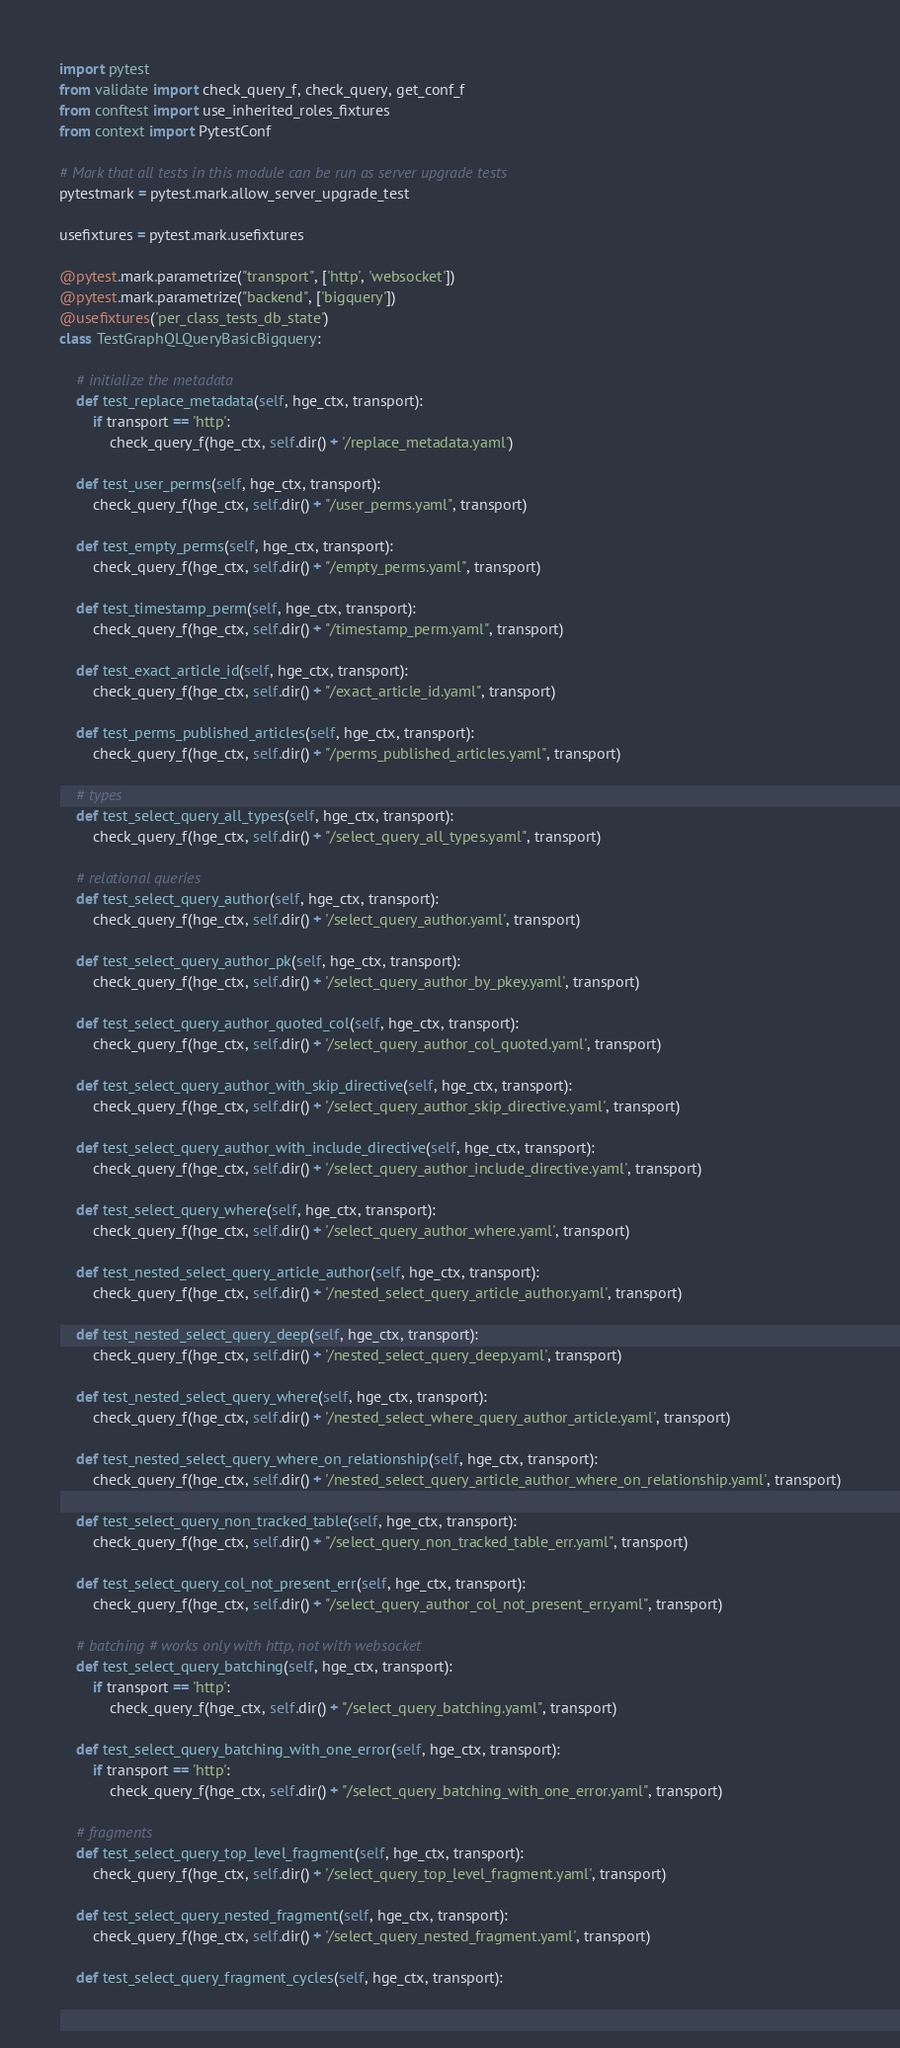Convert code to text. <code><loc_0><loc_0><loc_500><loc_500><_Python_>import pytest
from validate import check_query_f, check_query, get_conf_f
from conftest import use_inherited_roles_fixtures
from context import PytestConf

# Mark that all tests in this module can be run as server upgrade tests
pytestmark = pytest.mark.allow_server_upgrade_test

usefixtures = pytest.mark.usefixtures

@pytest.mark.parametrize("transport", ['http', 'websocket'])
@pytest.mark.parametrize("backend", ['bigquery'])
@usefixtures('per_class_tests_db_state')
class TestGraphQLQueryBasicBigquery:

    # initialize the metadata
    def test_replace_metadata(self, hge_ctx, transport):
        if transport == 'http':
            check_query_f(hge_ctx, self.dir() + '/replace_metadata.yaml')

    def test_user_perms(self, hge_ctx, transport):
        check_query_f(hge_ctx, self.dir() + "/user_perms.yaml", transport)

    def test_empty_perms(self, hge_ctx, transport):
        check_query_f(hge_ctx, self.dir() + "/empty_perms.yaml", transport)

    def test_timestamp_perm(self, hge_ctx, transport):
        check_query_f(hge_ctx, self.dir() + "/timestamp_perm.yaml", transport)

    def test_exact_article_id(self, hge_ctx, transport):
        check_query_f(hge_ctx, self.dir() + "/exact_article_id.yaml", transport)

    def test_perms_published_articles(self, hge_ctx, transport):
        check_query_f(hge_ctx, self.dir() + "/perms_published_articles.yaml", transport)

    # types
    def test_select_query_all_types(self, hge_ctx, transport):
        check_query_f(hge_ctx, self.dir() + "/select_query_all_types.yaml", transport)

    # relational queries
    def test_select_query_author(self, hge_ctx, transport):
        check_query_f(hge_ctx, self.dir() + '/select_query_author.yaml', transport)

    def test_select_query_author_pk(self, hge_ctx, transport):
        check_query_f(hge_ctx, self.dir() + '/select_query_author_by_pkey.yaml', transport)

    def test_select_query_author_quoted_col(self, hge_ctx, transport):
        check_query_f(hge_ctx, self.dir() + '/select_query_author_col_quoted.yaml', transport)

    def test_select_query_author_with_skip_directive(self, hge_ctx, transport):
        check_query_f(hge_ctx, self.dir() + '/select_query_author_skip_directive.yaml', transport)

    def test_select_query_author_with_include_directive(self, hge_ctx, transport):
        check_query_f(hge_ctx, self.dir() + '/select_query_author_include_directive.yaml', transport)

    def test_select_query_where(self, hge_ctx, transport):
        check_query_f(hge_ctx, self.dir() + '/select_query_author_where.yaml', transport)

    def test_nested_select_query_article_author(self, hge_ctx, transport):
        check_query_f(hge_ctx, self.dir() + '/nested_select_query_article_author.yaml', transport)

    def test_nested_select_query_deep(self, hge_ctx, transport):
        check_query_f(hge_ctx, self.dir() + '/nested_select_query_deep.yaml', transport)

    def test_nested_select_query_where(self, hge_ctx, transport):
        check_query_f(hge_ctx, self.dir() + '/nested_select_where_query_author_article.yaml', transport)

    def test_nested_select_query_where_on_relationship(self, hge_ctx, transport):
        check_query_f(hge_ctx, self.dir() + '/nested_select_query_article_author_where_on_relationship.yaml', transport)

    def test_select_query_non_tracked_table(self, hge_ctx, transport):
        check_query_f(hge_ctx, self.dir() + "/select_query_non_tracked_table_err.yaml", transport)

    def test_select_query_col_not_present_err(self, hge_ctx, transport):
        check_query_f(hge_ctx, self.dir() + "/select_query_author_col_not_present_err.yaml", transport)

    # batching # works only with http, not with websocket
    def test_select_query_batching(self, hge_ctx, transport):
        if transport == 'http':
            check_query_f(hge_ctx, self.dir() + "/select_query_batching.yaml", transport)

    def test_select_query_batching_with_one_error(self, hge_ctx, transport):
        if transport == 'http':
            check_query_f(hge_ctx, self.dir() + "/select_query_batching_with_one_error.yaml", transport)

    # fragments
    def test_select_query_top_level_fragment(self, hge_ctx, transport):
        check_query_f(hge_ctx, self.dir() + '/select_query_top_level_fragment.yaml', transport)

    def test_select_query_nested_fragment(self, hge_ctx, transport):
        check_query_f(hge_ctx, self.dir() + '/select_query_nested_fragment.yaml', transport)

    def test_select_query_fragment_cycles(self, hge_ctx, transport):</code> 